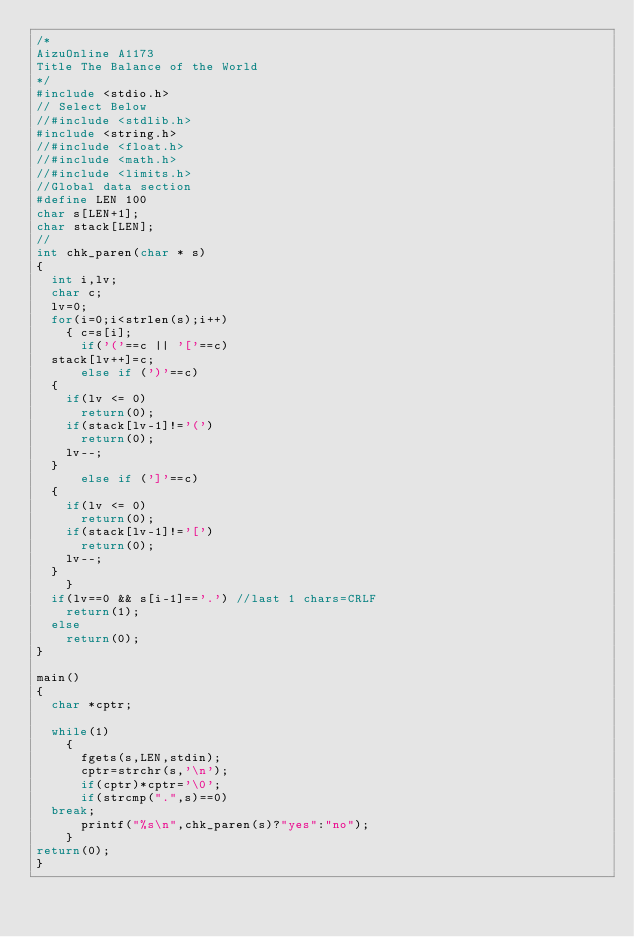Convert code to text. <code><loc_0><loc_0><loc_500><loc_500><_C_>/*
AizuOnline A1173
Title The Balance of the World
*/
#include <stdio.h>
// Select Below
//#include <stdlib.h>
#include <string.h>
//#include <float.h>
//#include <math.h>
//#include <limits.h>
//Global data section
#define LEN 100
char s[LEN+1];
char stack[LEN];
//
int chk_paren(char * s)
{
  int i,lv;
  char c;
  lv=0;
  for(i=0;i<strlen(s);i++)
    { c=s[i];
      if('('==c || '['==c)
	stack[lv++]=c;
      else if (')'==c)
	{
	  if(lv <= 0)
	    return(0);
	  if(stack[lv-1]!='(')
	    return(0);
	  lv--;
	}
      else if (']'==c)
	{
	  if(lv <= 0)
	    return(0);
	  if(stack[lv-1]!='[')
	    return(0);
	  lv--;
	}
    }
  if(lv==0 && s[i-1]=='.') //last 1 chars=CRLF
    return(1);
  else
    return(0);
}

main()
{
  char *cptr;

  while(1)
    {
      fgets(s,LEN,stdin);
      cptr=strchr(s,'\n');
      if(cptr)*cptr='\0';
      if(strcmp(".",s)==0)
	break;
      printf("%s\n",chk_paren(s)?"yes":"no");
    }
return(0);
}</code> 